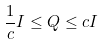<formula> <loc_0><loc_0><loc_500><loc_500>\frac { 1 } { c } I \leq Q \leq c I</formula> 